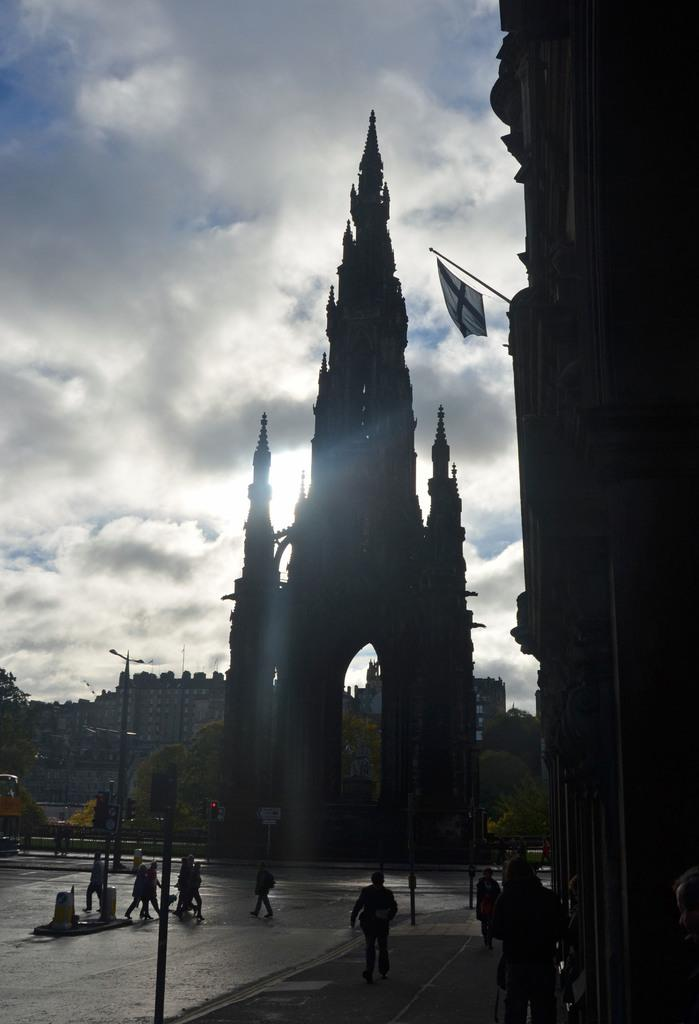What type of structures can be seen in the image? There are buildings in the image. What other natural elements are present in the image? There are trees in the image. Are there any human figures visible in the image? Yes, there are people in the image. What else can be seen in the image besides buildings, trees, and people? There are poles in the image. Where is the flag located in the image? The flag is hanging on a pole on the right side of the image. What can be seen in the background of the image? The sky is visible in the background of the image. What type of furniture can be seen in the image? There is no furniture present in the image. How is the gun being used by the people in the image? There is no gun present in the image. 